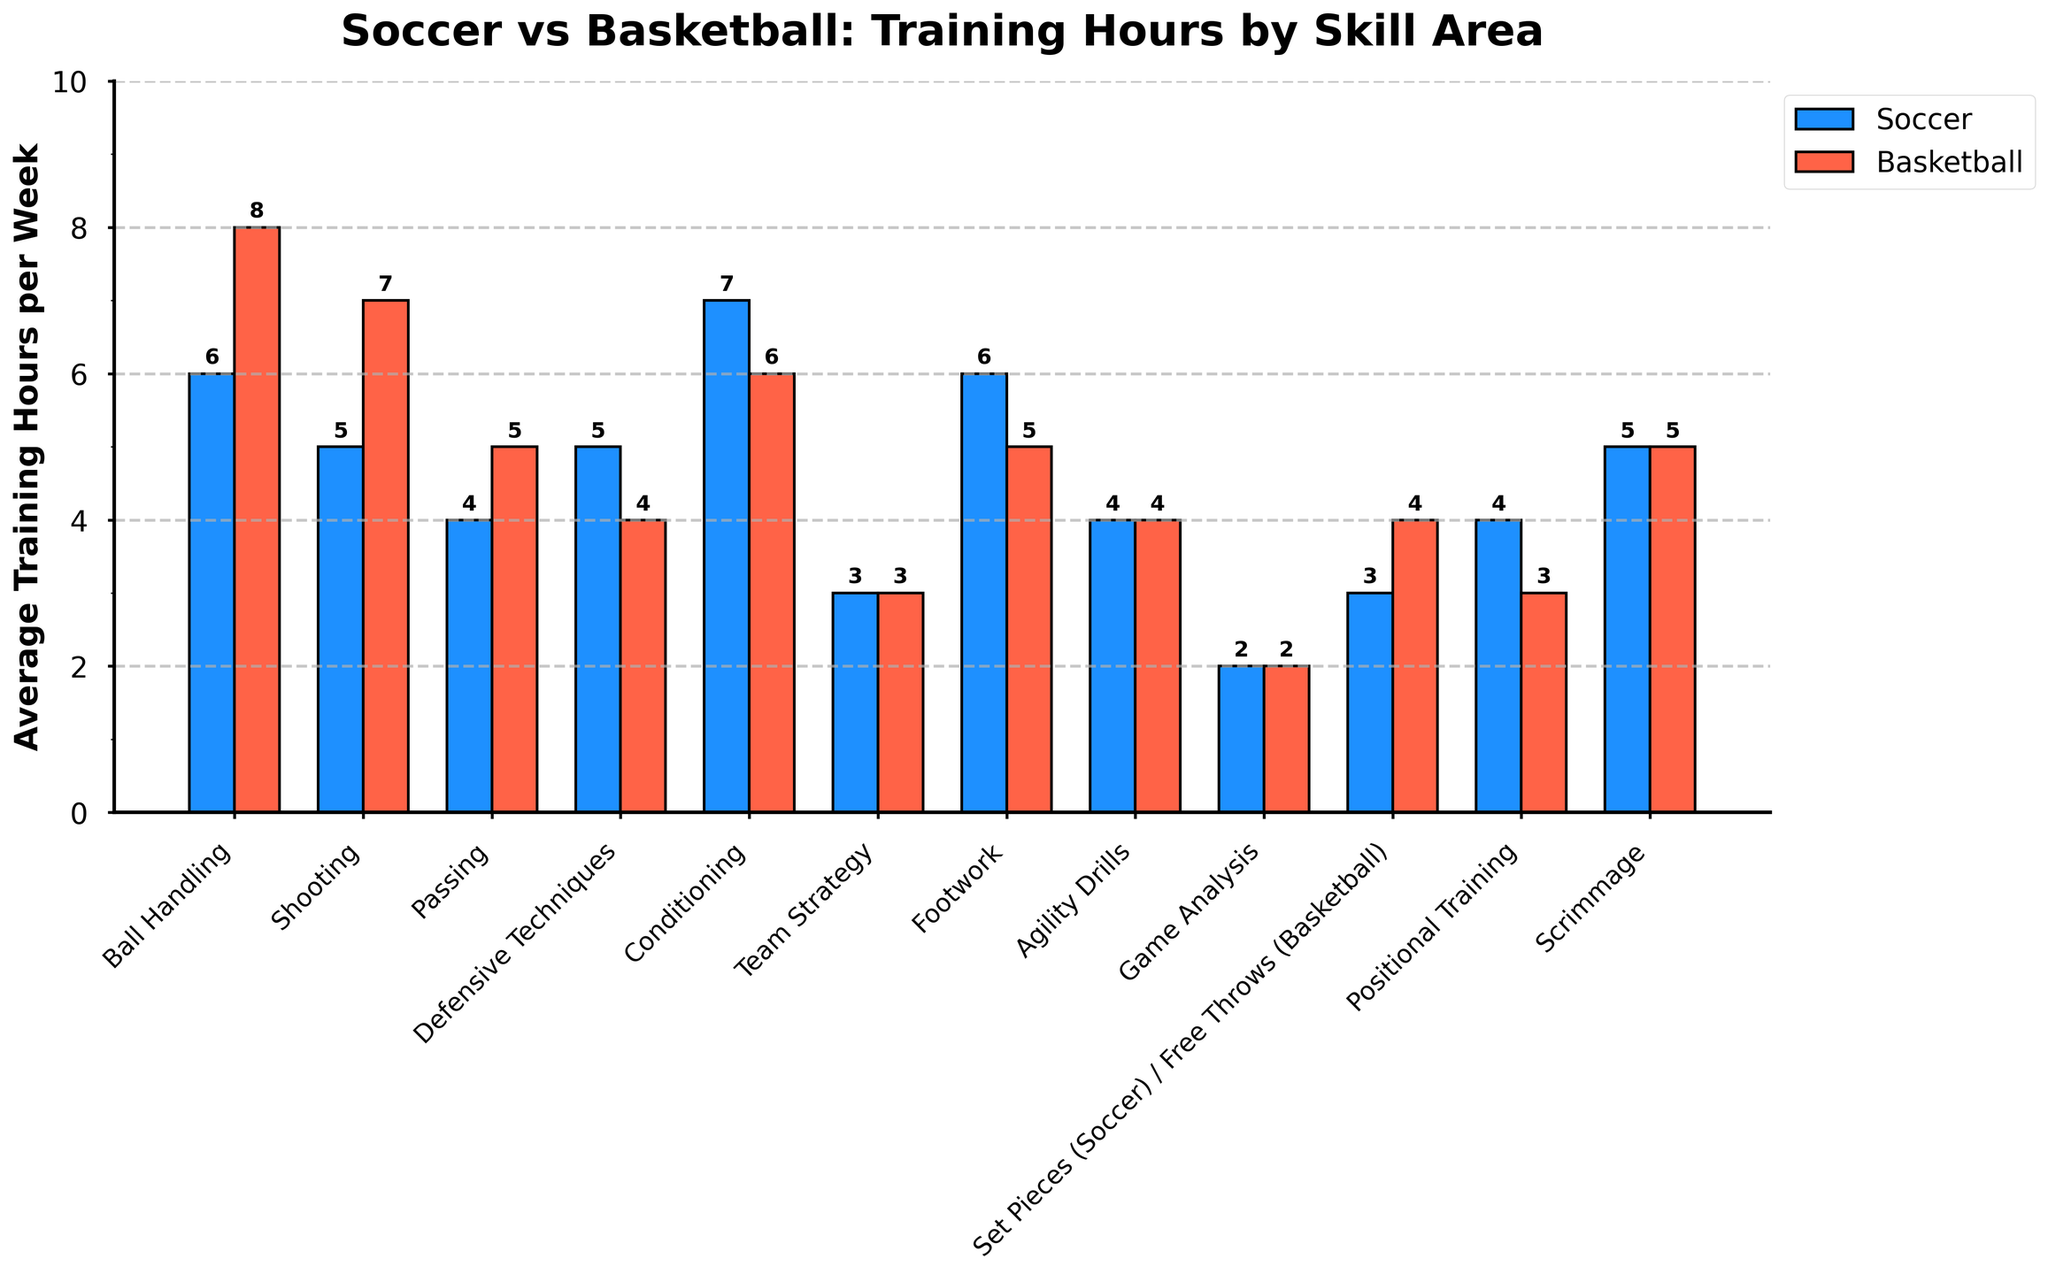Which skill area has the highest average training hours in soccer? Observing the height of the bars for soccer, 'Conditioning' has the tallest bar at 7 hours
Answer: Conditioning Which skill area has the equal average training hours for both soccer and basketball? Looking at the bars where both bar heights are the same, 'Team Strategy', 'Agility Drills', 'Game Analysis', and 'Scrimmage' all have equal heights of 3, 4, 2, and 5 hours respectively
Answer: Team Strategy, Agility Drills, Game Analysis, Scrimmage How many more hours are spent on footwork training in soccer compared to basketball? The bar for 'Footwork' in soccer is 6 hours, and in basketball it is 5 hours. The difference is 6 - 5 = 1 hour
Answer: 1 hour Which skill area has the greatest difference in average training hours between soccer and basketball? Observing the differences manually, 'Shooting' has a difference of 7 (basketball) - 5 (soccer) = 2 hours
Answer: Shooting What is the total average training hours per week for all skill areas combined in basketball? Summing up the heights of all basketball bars: 8 + 7 + 5 + 4 + 6 + 3 + 5 + 4 + 2 + 4 + 3 + 5 = 56 hours
Answer: 56 hours 